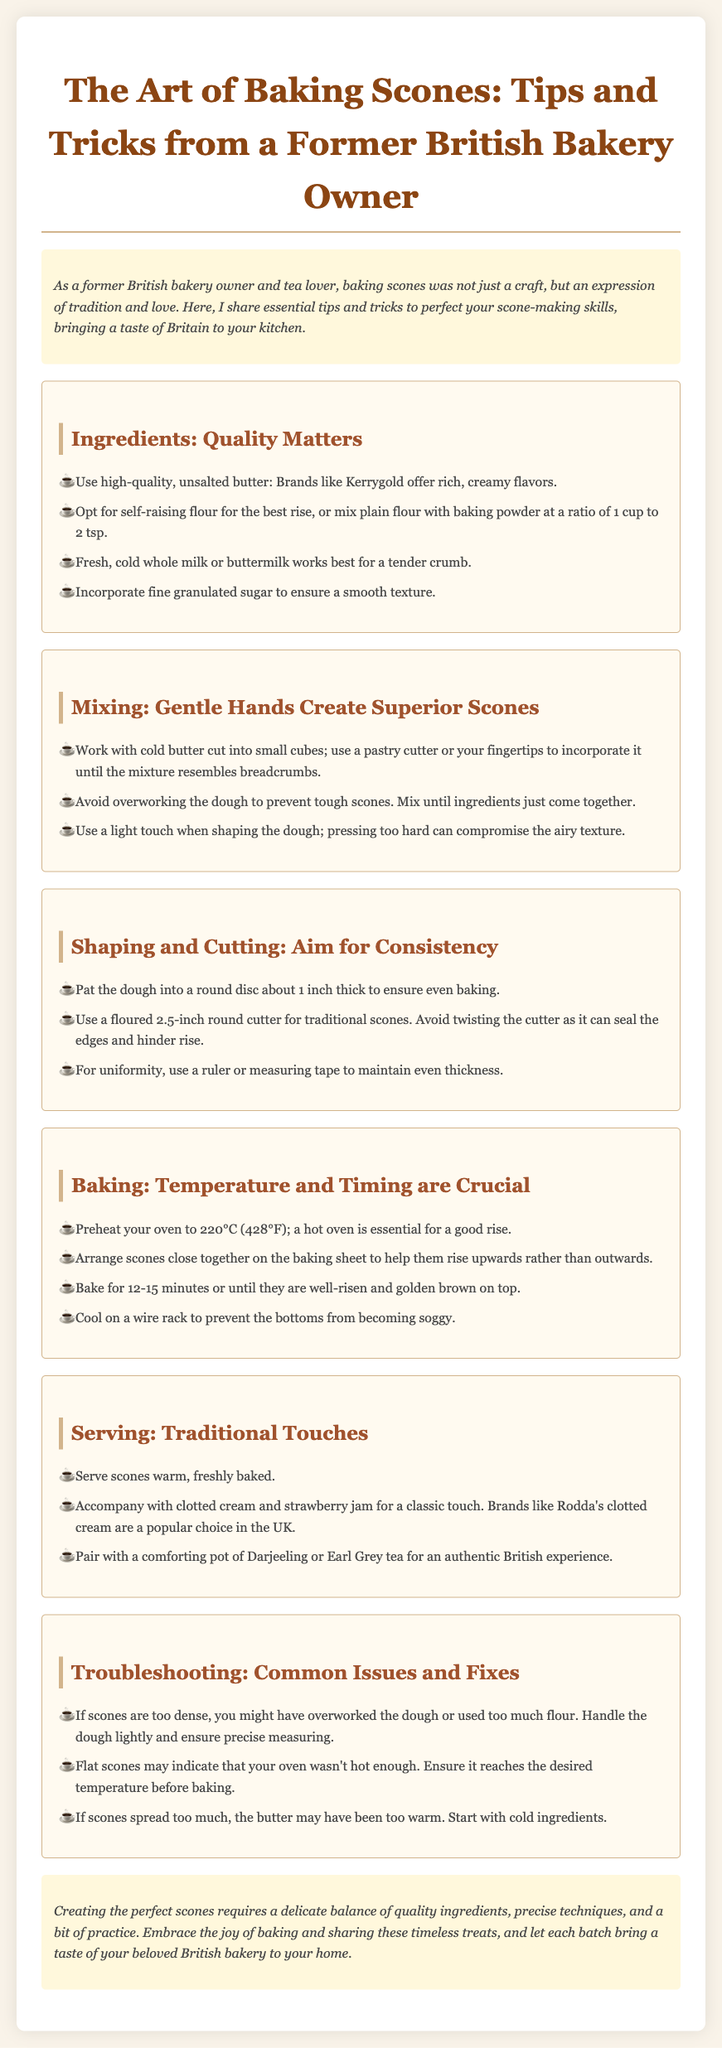what is the main purpose of the guide? The guide shares essential tips and tricks to perfect scone-making skills, bringing a taste of Britain to your kitchen.
Answer: perfect scone-making skills what type of flour is recommended for scone baking? The document suggests using self-raising flour or mixing plain flour with baking powder at a ratio of 1 cup to 2 tsp.
Answer: self-raising flour how long should scones be baked for? The baking time according to the guide is 12-15 minutes.
Answer: 12-15 minutes what should scones be served with for a classic British touch? It is recommended to serve scones with clotted cream and strawberry jam.
Answer: clotted cream and strawberry jam what is a common issue if scones are too dense? If scones are too dense, it could indicate overworked dough or too much flour used.
Answer: overworked dough which type of tea is suggested for pairing with scones? The guide recommends pairing scones with a comforting pot of Darjeeling or Earl Grey tea.
Answer: Darjeeling or Earl Grey tea what temperature should the oven be preheated to for baking scones? The recommended oven temperature for baking scones is 220°C (428°F).
Answer: 220°C (428°F) how should the dough be handled to avoid tough scones? The dough should be mixed until the ingredients just come together to avoid tough scones.
Answer: mixed just until combined what is one troubleshooting tip for flat scones? A flat scone may indicate that the oven wasn't hot enough.
Answer: oven not hot enough 